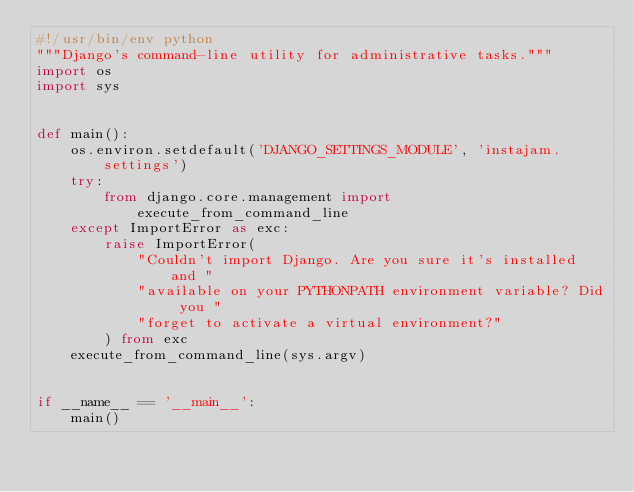<code> <loc_0><loc_0><loc_500><loc_500><_Python_>#!/usr/bin/env python
"""Django's command-line utility for administrative tasks."""
import os
import sys


def main():
    os.environ.setdefault('DJANGO_SETTINGS_MODULE', 'instajam.settings')
    try:
        from django.core.management import execute_from_command_line
    except ImportError as exc:
        raise ImportError(
            "Couldn't import Django. Are you sure it's installed and "
            "available on your PYTHONPATH environment variable? Did you "
            "forget to activate a virtual environment?"
        ) from exc
    execute_from_command_line(sys.argv)


if __name__ == '__main__':
    main()
</code> 